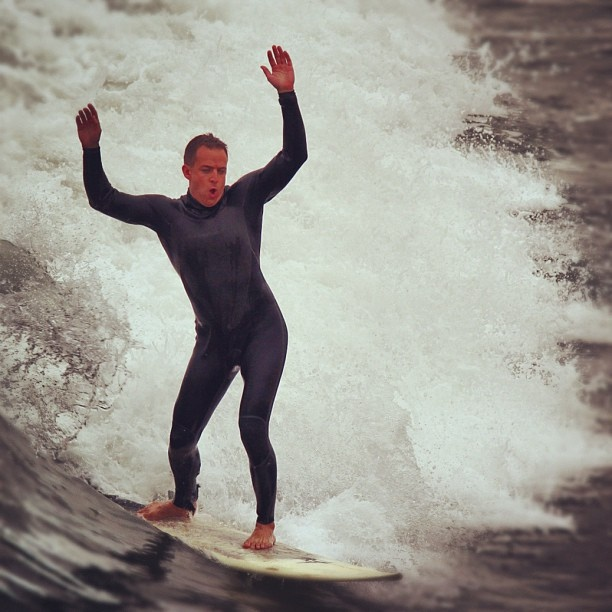Describe the objects in this image and their specific colors. I can see people in darkgray, black, maroon, and brown tones and surfboard in darkgray, tan, beige, and gray tones in this image. 